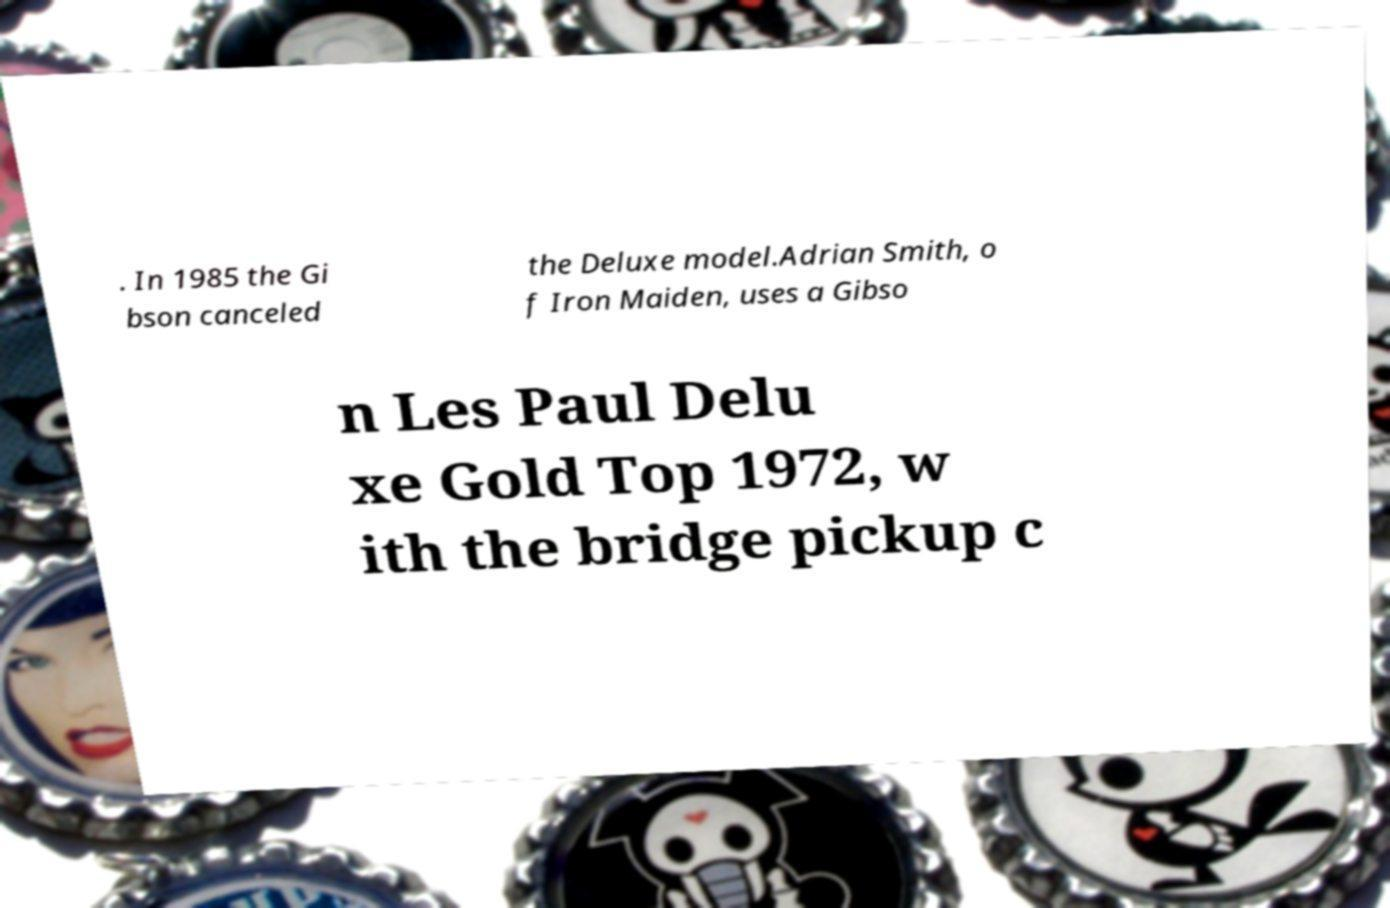Please identify and transcribe the text found in this image. . In 1985 the Gi bson canceled the Deluxe model.Adrian Smith, o f Iron Maiden, uses a Gibso n Les Paul Delu xe Gold Top 1972, w ith the bridge pickup c 